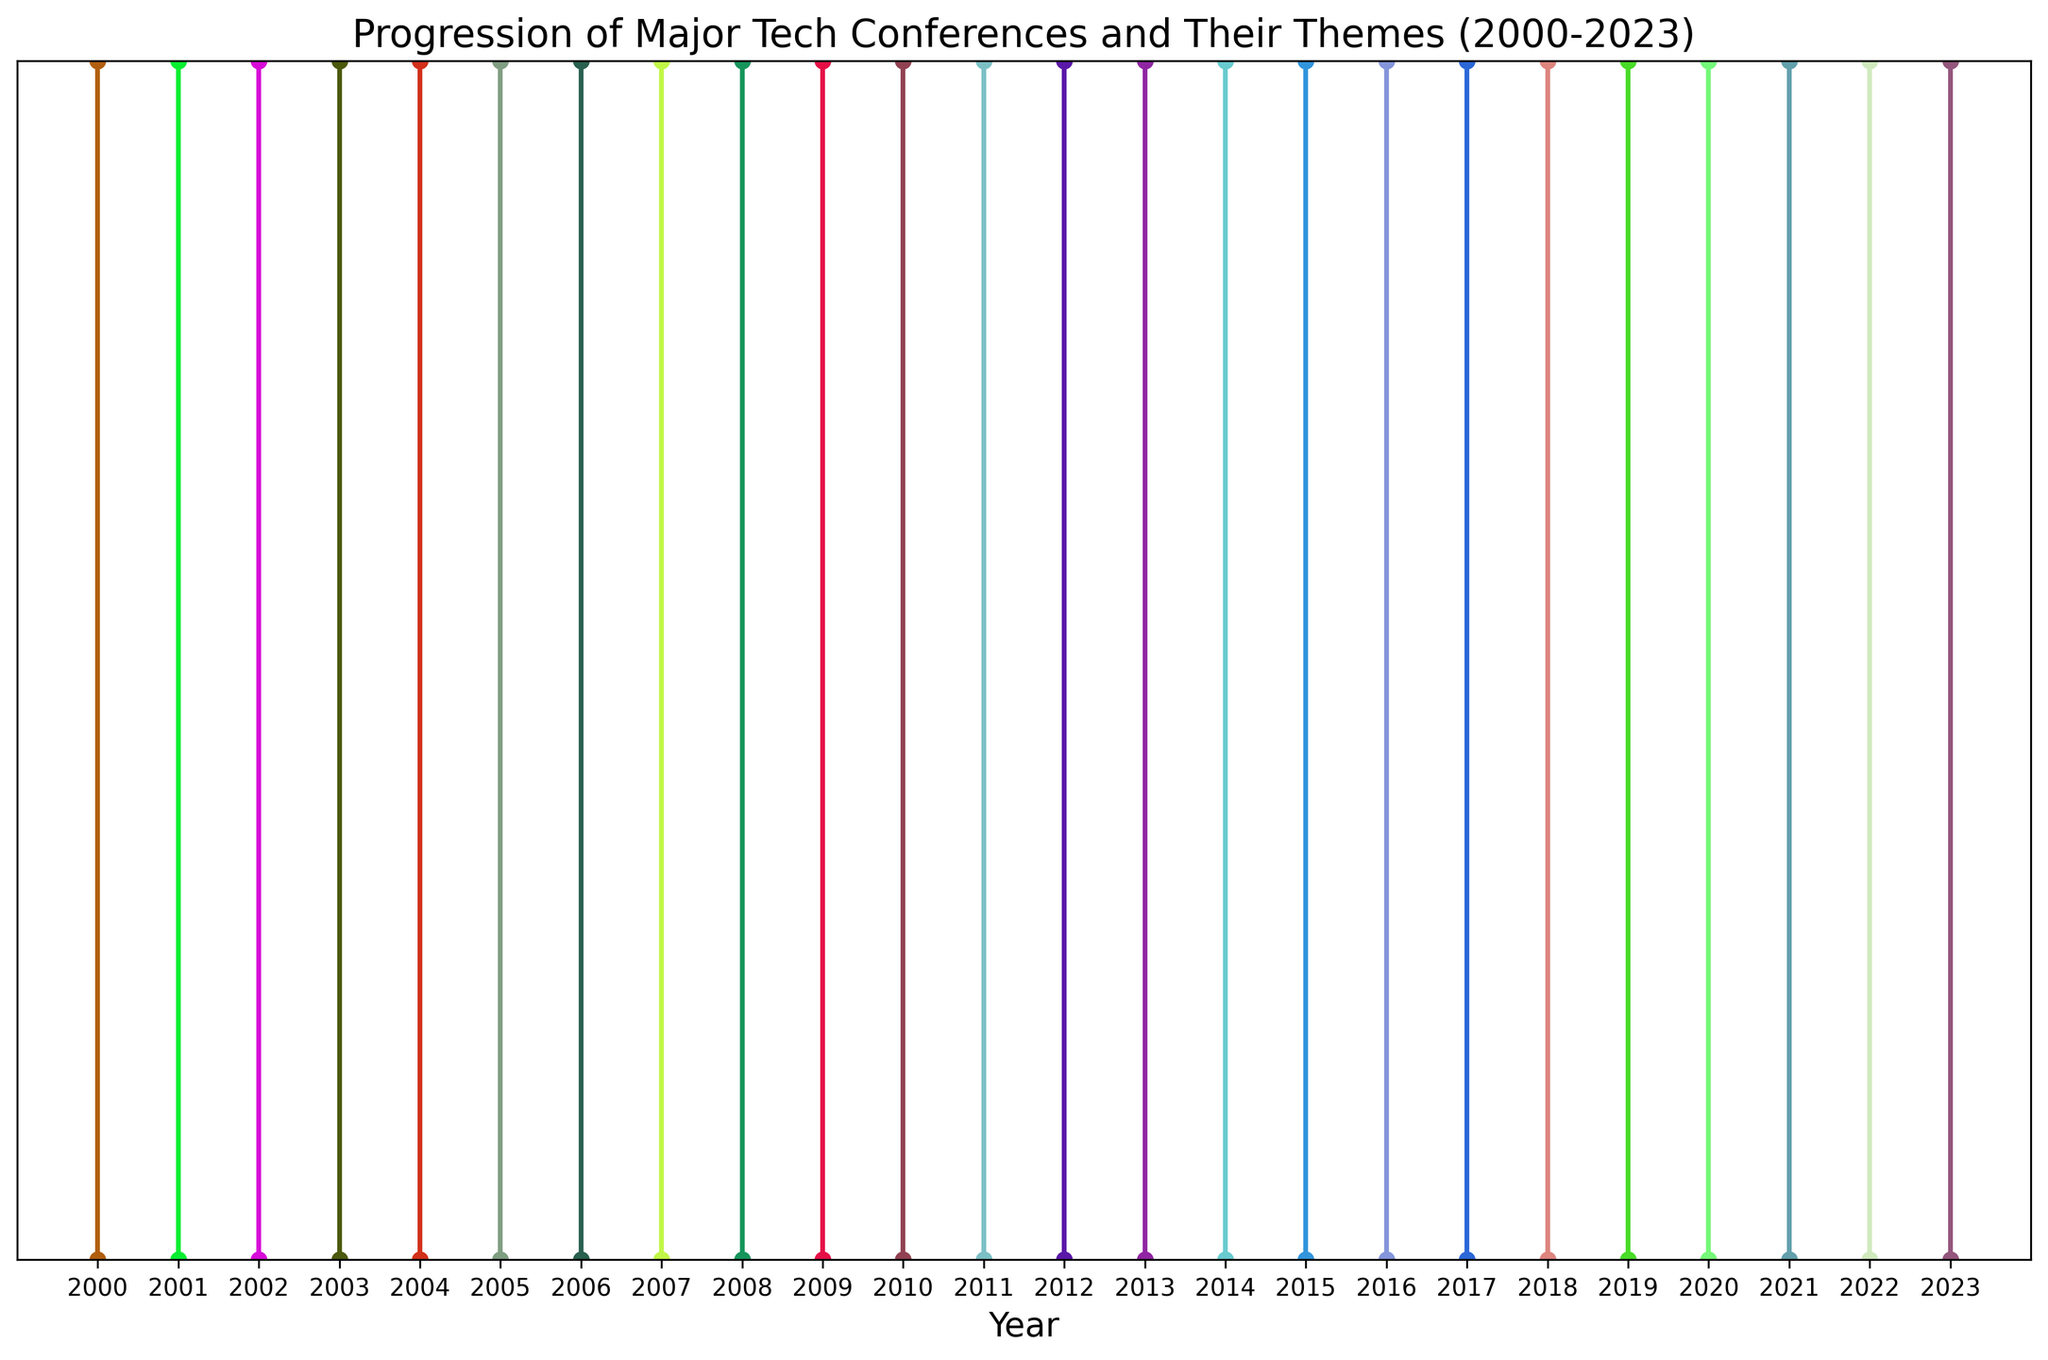What was the theme of the conference in 2013? Look at the point labeled "Amazon re:Invent" in 2013 and read the annotated theme next to it.
Answer: Cloud Computing Which conference has the theme "Interactive Media"? Identify the annotation with the theme "Interactive Media" and find the corresponding conference name (South by Southwest - SXSW) and the year 2010
Answer: South by Southwest (SXSW) How many conferences had their themes related to cybersecurity or information security? Count the annotations with themes associated with cybersecurity or information security: DEF CON (2006), Black Hat USA (2017)
Answer: 2 Compare the themes between 2008 and 2011. Which year had themes more related to hardware/software development? In 2008, the theme is "Indie Games" (Game Developers Conference). In 2011, the theme is "Android Development" (Google I/O), which is related to software development.
Answer: 2011 What is the median year of the conferences listed in the figure? List all years and find the median: 2000, 2001, 2002, 2003, 2004, 2005, 2006, 2007, 2008, 2009, 2010, 2011, 2012, 2013, 2014, 2015, 2016, 2017, 2018, 2019, 2020, 2021, 2022, 2023. The median is the middle value (2011) in the ordered list since there are 24 years.
Answer: 2011 Which conference appeared first and what was its theme? Identify the earliest year (2000) and find the corresponding conference: International Conference on Software Engineering (ICSE) with the theme "Advances in Software Engineering"
Answer: International Conference on Software Engineering (ICSE), Advances in Software Engineering What are the themes of tech conferences that occurred after 2020? Observe the annotations for years 2020 onwards: 2020 (Virtual and Augmented Reality), 2021 (Data Science for Social Good), 2022 (Robotics and Automation), 2023 (Computer Vision)
Answer: Virtual and Augmented Reality, Data Science for Social Good, Robotics and Automation, Computer Vision Which year's conference focused on social media technologies, and what was the exact theme? Find the annotation with a theme related to social media: 2014, (F8- Facebook Developer Conference) with the theme "Social Media APIs"
Answer: 2014, Social Media APIs What is the average interval between the first and last conference? Calculate the interval: 2023 - 2000 = 23 years. Divide by the number of conferences: 23/(number of conferences - 1): 23/23 = approximately 1 year per conference
Answer: Approximately 1 year per conference 